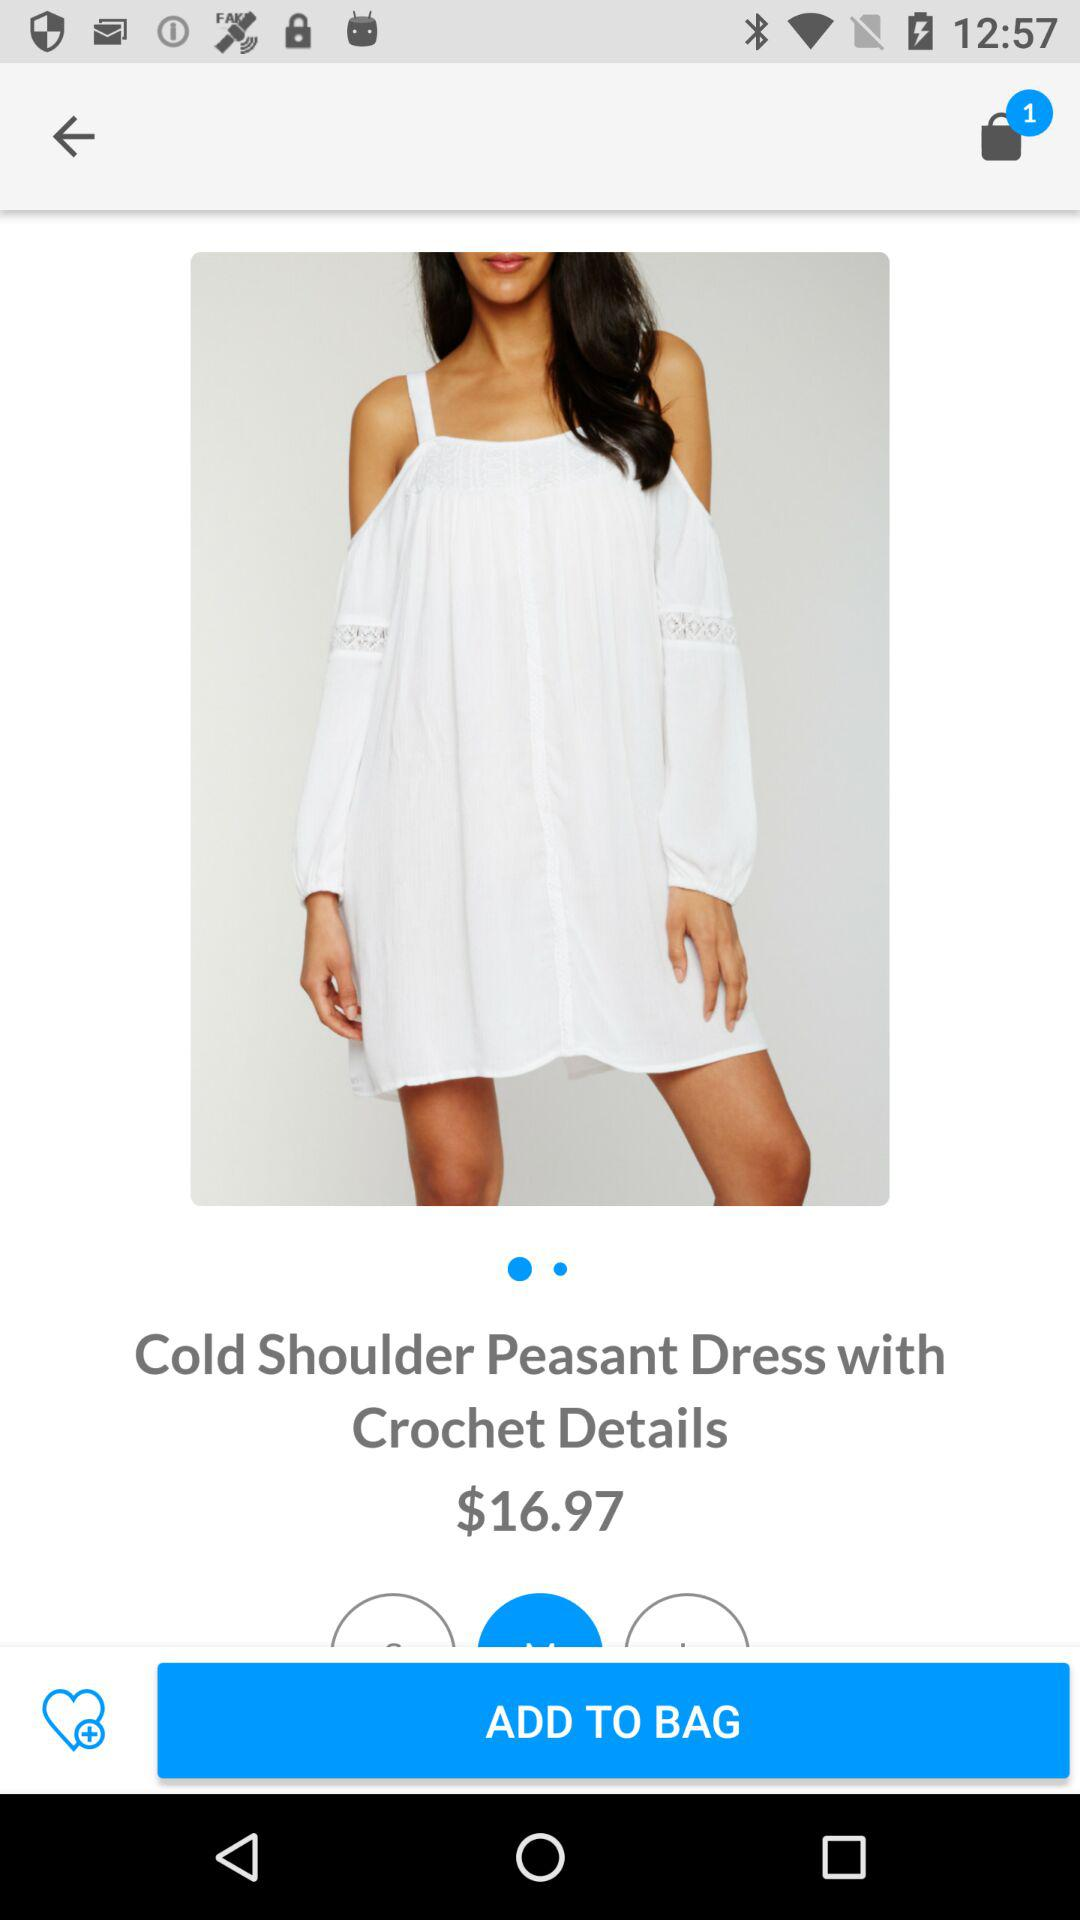How many items are added to the bag? There is 1 item added to the bag. 